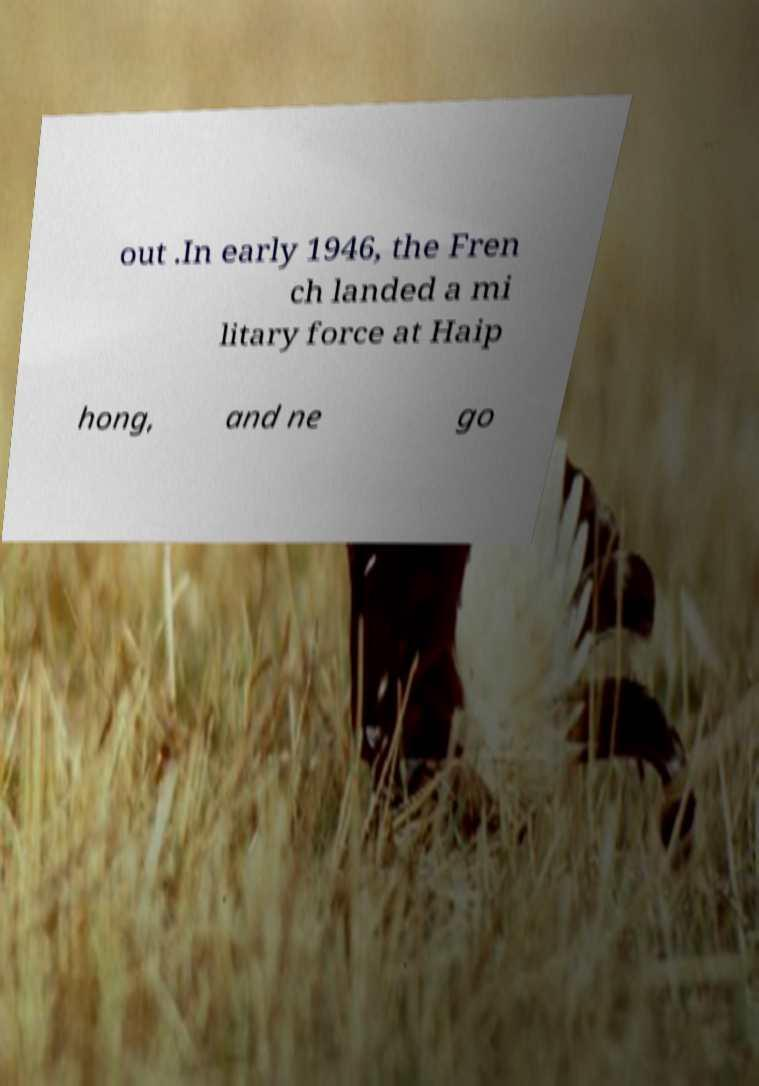There's text embedded in this image that I need extracted. Can you transcribe it verbatim? out .In early 1946, the Fren ch landed a mi litary force at Haip hong, and ne go 